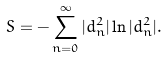<formula> <loc_0><loc_0><loc_500><loc_500>S = - \sum _ { n = 0 } ^ { \infty } | d _ { n } ^ { 2 } | \ln | d _ { n } ^ { 2 } | .</formula> 